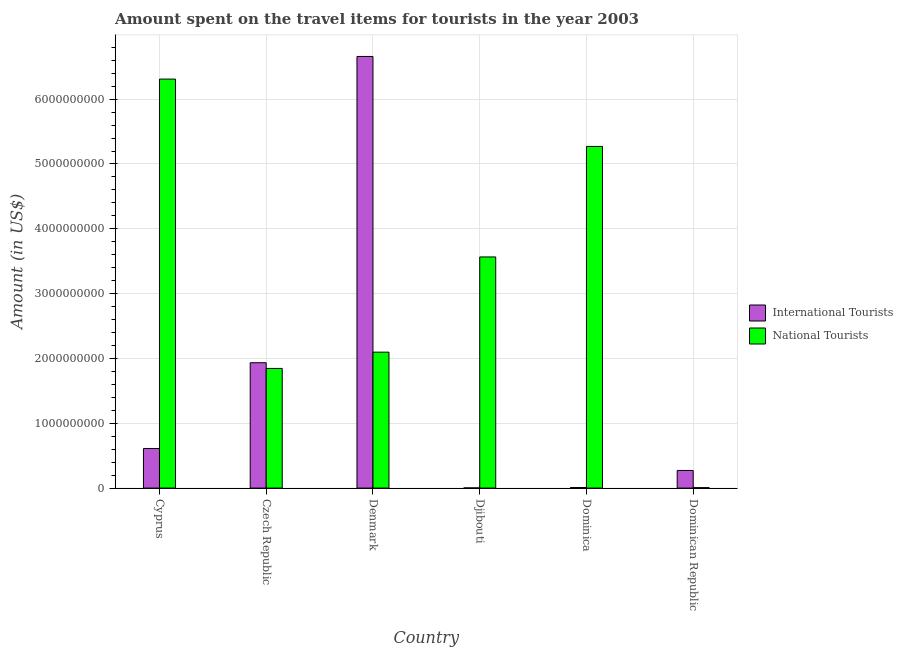How many different coloured bars are there?
Your answer should be compact. 2. Are the number of bars per tick equal to the number of legend labels?
Make the answer very short. Yes. How many bars are there on the 4th tick from the left?
Your answer should be very brief. 2. How many bars are there on the 2nd tick from the right?
Offer a terse response. 2. What is the label of the 4th group of bars from the left?
Give a very brief answer. Djibouti. What is the amount spent on travel items of national tourists in Djibouti?
Ensure brevity in your answer.  3.57e+09. Across all countries, what is the maximum amount spent on travel items of national tourists?
Your answer should be very brief. 6.31e+09. Across all countries, what is the minimum amount spent on travel items of national tourists?
Provide a short and direct response. 6.90e+06. In which country was the amount spent on travel items of national tourists maximum?
Offer a terse response. Cyprus. In which country was the amount spent on travel items of international tourists minimum?
Ensure brevity in your answer.  Djibouti. What is the total amount spent on travel items of national tourists in the graph?
Offer a terse response. 1.91e+1. What is the difference between the amount spent on travel items of international tourists in Cyprus and that in Djibouti?
Provide a short and direct response. 6.08e+08. What is the difference between the amount spent on travel items of international tourists in Denmark and the amount spent on travel items of national tourists in Djibouti?
Keep it short and to the point. 3.09e+09. What is the average amount spent on travel items of national tourists per country?
Ensure brevity in your answer.  3.18e+09. What is the difference between the amount spent on travel items of national tourists and amount spent on travel items of international tourists in Denmark?
Your answer should be very brief. -4.56e+09. In how many countries, is the amount spent on travel items of national tourists greater than 6000000000 US$?
Make the answer very short. 1. What is the ratio of the amount spent on travel items of international tourists in Czech Republic to that in Djibouti?
Provide a short and direct response. 690.71. Is the difference between the amount spent on travel items of international tourists in Cyprus and Dominica greater than the difference between the amount spent on travel items of national tourists in Cyprus and Dominica?
Your response must be concise. No. What is the difference between the highest and the second highest amount spent on travel items of international tourists?
Your answer should be very brief. 4.72e+09. What is the difference between the highest and the lowest amount spent on travel items of international tourists?
Offer a very short reply. 6.66e+09. Is the sum of the amount spent on travel items of international tourists in Djibouti and Dominican Republic greater than the maximum amount spent on travel items of national tourists across all countries?
Provide a short and direct response. No. What does the 2nd bar from the left in Dominican Republic represents?
Your answer should be very brief. National Tourists. What does the 1st bar from the right in Dominica represents?
Your response must be concise. National Tourists. How many bars are there?
Provide a succinct answer. 12. Where does the legend appear in the graph?
Make the answer very short. Center right. What is the title of the graph?
Offer a terse response. Amount spent on the travel items for tourists in the year 2003. Does "Number of arrivals" appear as one of the legend labels in the graph?
Your response must be concise. No. What is the Amount (in US$) in International Tourists in Cyprus?
Provide a succinct answer. 6.11e+08. What is the Amount (in US$) of National Tourists in Cyprus?
Offer a very short reply. 6.31e+09. What is the Amount (in US$) of International Tourists in Czech Republic?
Your response must be concise. 1.93e+09. What is the Amount (in US$) in National Tourists in Czech Republic?
Your response must be concise. 1.85e+09. What is the Amount (in US$) in International Tourists in Denmark?
Give a very brief answer. 6.66e+09. What is the Amount (in US$) of National Tourists in Denmark?
Give a very brief answer. 2.10e+09. What is the Amount (in US$) of International Tourists in Djibouti?
Your answer should be very brief. 2.80e+06. What is the Amount (in US$) of National Tourists in Djibouti?
Offer a very short reply. 3.57e+09. What is the Amount (in US$) of International Tourists in Dominica?
Give a very brief answer. 9.00e+06. What is the Amount (in US$) of National Tourists in Dominica?
Your response must be concise. 5.27e+09. What is the Amount (in US$) of International Tourists in Dominican Republic?
Keep it short and to the point. 2.72e+08. What is the Amount (in US$) in National Tourists in Dominican Republic?
Provide a short and direct response. 6.90e+06. Across all countries, what is the maximum Amount (in US$) in International Tourists?
Provide a short and direct response. 6.66e+09. Across all countries, what is the maximum Amount (in US$) in National Tourists?
Make the answer very short. 6.31e+09. Across all countries, what is the minimum Amount (in US$) of International Tourists?
Provide a succinct answer. 2.80e+06. Across all countries, what is the minimum Amount (in US$) in National Tourists?
Your answer should be very brief. 6.90e+06. What is the total Amount (in US$) of International Tourists in the graph?
Provide a short and direct response. 9.49e+09. What is the total Amount (in US$) in National Tourists in the graph?
Provide a short and direct response. 1.91e+1. What is the difference between the Amount (in US$) in International Tourists in Cyprus and that in Czech Republic?
Offer a terse response. -1.32e+09. What is the difference between the Amount (in US$) of National Tourists in Cyprus and that in Czech Republic?
Provide a short and direct response. 4.46e+09. What is the difference between the Amount (in US$) in International Tourists in Cyprus and that in Denmark?
Make the answer very short. -6.05e+09. What is the difference between the Amount (in US$) of National Tourists in Cyprus and that in Denmark?
Your answer should be very brief. 4.21e+09. What is the difference between the Amount (in US$) in International Tourists in Cyprus and that in Djibouti?
Keep it short and to the point. 6.08e+08. What is the difference between the Amount (in US$) of National Tourists in Cyprus and that in Djibouti?
Provide a succinct answer. 2.74e+09. What is the difference between the Amount (in US$) of International Tourists in Cyprus and that in Dominica?
Provide a succinct answer. 6.02e+08. What is the difference between the Amount (in US$) in National Tourists in Cyprus and that in Dominica?
Your answer should be compact. 1.04e+09. What is the difference between the Amount (in US$) in International Tourists in Cyprus and that in Dominican Republic?
Keep it short and to the point. 3.39e+08. What is the difference between the Amount (in US$) of National Tourists in Cyprus and that in Dominican Republic?
Ensure brevity in your answer.  6.30e+09. What is the difference between the Amount (in US$) in International Tourists in Czech Republic and that in Denmark?
Make the answer very short. -4.72e+09. What is the difference between the Amount (in US$) of National Tourists in Czech Republic and that in Denmark?
Give a very brief answer. -2.51e+08. What is the difference between the Amount (in US$) in International Tourists in Czech Republic and that in Djibouti?
Provide a succinct answer. 1.93e+09. What is the difference between the Amount (in US$) in National Tourists in Czech Republic and that in Djibouti?
Provide a succinct answer. -1.72e+09. What is the difference between the Amount (in US$) of International Tourists in Czech Republic and that in Dominica?
Offer a very short reply. 1.92e+09. What is the difference between the Amount (in US$) of National Tourists in Czech Republic and that in Dominica?
Offer a terse response. -3.42e+09. What is the difference between the Amount (in US$) in International Tourists in Czech Republic and that in Dominican Republic?
Give a very brief answer. 1.66e+09. What is the difference between the Amount (in US$) of National Tourists in Czech Republic and that in Dominican Republic?
Your answer should be very brief. 1.84e+09. What is the difference between the Amount (in US$) in International Tourists in Denmark and that in Djibouti?
Your answer should be very brief. 6.66e+09. What is the difference between the Amount (in US$) in National Tourists in Denmark and that in Djibouti?
Keep it short and to the point. -1.47e+09. What is the difference between the Amount (in US$) in International Tourists in Denmark and that in Dominica?
Offer a terse response. 6.65e+09. What is the difference between the Amount (in US$) of National Tourists in Denmark and that in Dominica?
Make the answer very short. -3.17e+09. What is the difference between the Amount (in US$) of International Tourists in Denmark and that in Dominican Republic?
Keep it short and to the point. 6.39e+09. What is the difference between the Amount (in US$) in National Tourists in Denmark and that in Dominican Republic?
Make the answer very short. 2.09e+09. What is the difference between the Amount (in US$) of International Tourists in Djibouti and that in Dominica?
Provide a succinct answer. -6.20e+06. What is the difference between the Amount (in US$) of National Tourists in Djibouti and that in Dominica?
Give a very brief answer. -1.70e+09. What is the difference between the Amount (in US$) in International Tourists in Djibouti and that in Dominican Republic?
Make the answer very short. -2.69e+08. What is the difference between the Amount (in US$) in National Tourists in Djibouti and that in Dominican Republic?
Offer a very short reply. 3.56e+09. What is the difference between the Amount (in US$) in International Tourists in Dominica and that in Dominican Republic?
Your response must be concise. -2.63e+08. What is the difference between the Amount (in US$) in National Tourists in Dominica and that in Dominican Republic?
Offer a very short reply. 5.26e+09. What is the difference between the Amount (in US$) of International Tourists in Cyprus and the Amount (in US$) of National Tourists in Czech Republic?
Your answer should be compact. -1.24e+09. What is the difference between the Amount (in US$) of International Tourists in Cyprus and the Amount (in US$) of National Tourists in Denmark?
Make the answer very short. -1.49e+09. What is the difference between the Amount (in US$) of International Tourists in Cyprus and the Amount (in US$) of National Tourists in Djibouti?
Your answer should be compact. -2.96e+09. What is the difference between the Amount (in US$) of International Tourists in Cyprus and the Amount (in US$) of National Tourists in Dominica?
Keep it short and to the point. -4.66e+09. What is the difference between the Amount (in US$) of International Tourists in Cyprus and the Amount (in US$) of National Tourists in Dominican Republic?
Give a very brief answer. 6.04e+08. What is the difference between the Amount (in US$) in International Tourists in Czech Republic and the Amount (in US$) in National Tourists in Denmark?
Provide a short and direct response. -1.63e+08. What is the difference between the Amount (in US$) in International Tourists in Czech Republic and the Amount (in US$) in National Tourists in Djibouti?
Offer a terse response. -1.63e+09. What is the difference between the Amount (in US$) in International Tourists in Czech Republic and the Amount (in US$) in National Tourists in Dominica?
Your response must be concise. -3.34e+09. What is the difference between the Amount (in US$) of International Tourists in Czech Republic and the Amount (in US$) of National Tourists in Dominican Republic?
Offer a very short reply. 1.93e+09. What is the difference between the Amount (in US$) of International Tourists in Denmark and the Amount (in US$) of National Tourists in Djibouti?
Give a very brief answer. 3.09e+09. What is the difference between the Amount (in US$) of International Tourists in Denmark and the Amount (in US$) of National Tourists in Dominica?
Ensure brevity in your answer.  1.39e+09. What is the difference between the Amount (in US$) of International Tourists in Denmark and the Amount (in US$) of National Tourists in Dominican Republic?
Make the answer very short. 6.65e+09. What is the difference between the Amount (in US$) of International Tourists in Djibouti and the Amount (in US$) of National Tourists in Dominica?
Provide a short and direct response. -5.27e+09. What is the difference between the Amount (in US$) of International Tourists in Djibouti and the Amount (in US$) of National Tourists in Dominican Republic?
Make the answer very short. -4.10e+06. What is the difference between the Amount (in US$) in International Tourists in Dominica and the Amount (in US$) in National Tourists in Dominican Republic?
Your answer should be compact. 2.10e+06. What is the average Amount (in US$) in International Tourists per country?
Provide a succinct answer. 1.58e+09. What is the average Amount (in US$) of National Tourists per country?
Give a very brief answer. 3.18e+09. What is the difference between the Amount (in US$) of International Tourists and Amount (in US$) of National Tourists in Cyprus?
Your response must be concise. -5.70e+09. What is the difference between the Amount (in US$) in International Tourists and Amount (in US$) in National Tourists in Czech Republic?
Your answer should be very brief. 8.80e+07. What is the difference between the Amount (in US$) of International Tourists and Amount (in US$) of National Tourists in Denmark?
Keep it short and to the point. 4.56e+09. What is the difference between the Amount (in US$) in International Tourists and Amount (in US$) in National Tourists in Djibouti?
Provide a succinct answer. -3.56e+09. What is the difference between the Amount (in US$) in International Tourists and Amount (in US$) in National Tourists in Dominica?
Keep it short and to the point. -5.26e+09. What is the difference between the Amount (in US$) of International Tourists and Amount (in US$) of National Tourists in Dominican Republic?
Your response must be concise. 2.65e+08. What is the ratio of the Amount (in US$) in International Tourists in Cyprus to that in Czech Republic?
Ensure brevity in your answer.  0.32. What is the ratio of the Amount (in US$) in National Tourists in Cyprus to that in Czech Republic?
Provide a succinct answer. 3.42. What is the ratio of the Amount (in US$) of International Tourists in Cyprus to that in Denmark?
Provide a short and direct response. 0.09. What is the ratio of the Amount (in US$) of National Tourists in Cyprus to that in Denmark?
Provide a succinct answer. 3.01. What is the ratio of the Amount (in US$) in International Tourists in Cyprus to that in Djibouti?
Ensure brevity in your answer.  218.21. What is the ratio of the Amount (in US$) of National Tourists in Cyprus to that in Djibouti?
Offer a terse response. 1.77. What is the ratio of the Amount (in US$) of International Tourists in Cyprus to that in Dominica?
Your response must be concise. 67.89. What is the ratio of the Amount (in US$) in National Tourists in Cyprus to that in Dominica?
Offer a terse response. 1.2. What is the ratio of the Amount (in US$) in International Tourists in Cyprus to that in Dominican Republic?
Your response must be concise. 2.25. What is the ratio of the Amount (in US$) in National Tourists in Cyprus to that in Dominican Republic?
Provide a succinct answer. 914.49. What is the ratio of the Amount (in US$) of International Tourists in Czech Republic to that in Denmark?
Make the answer very short. 0.29. What is the ratio of the Amount (in US$) in National Tourists in Czech Republic to that in Denmark?
Make the answer very short. 0.88. What is the ratio of the Amount (in US$) of International Tourists in Czech Republic to that in Djibouti?
Provide a short and direct response. 690.71. What is the ratio of the Amount (in US$) of National Tourists in Czech Republic to that in Djibouti?
Keep it short and to the point. 0.52. What is the ratio of the Amount (in US$) in International Tourists in Czech Republic to that in Dominica?
Offer a terse response. 214.89. What is the ratio of the Amount (in US$) in National Tourists in Czech Republic to that in Dominica?
Your response must be concise. 0.35. What is the ratio of the Amount (in US$) in International Tourists in Czech Republic to that in Dominican Republic?
Provide a succinct answer. 7.11. What is the ratio of the Amount (in US$) in National Tourists in Czech Republic to that in Dominican Republic?
Give a very brief answer. 267.54. What is the ratio of the Amount (in US$) of International Tourists in Denmark to that in Djibouti?
Provide a short and direct response. 2378.21. What is the ratio of the Amount (in US$) in National Tourists in Denmark to that in Djibouti?
Offer a terse response. 0.59. What is the ratio of the Amount (in US$) in International Tourists in Denmark to that in Dominica?
Offer a terse response. 739.89. What is the ratio of the Amount (in US$) of National Tourists in Denmark to that in Dominica?
Offer a very short reply. 0.4. What is the ratio of the Amount (in US$) of International Tourists in Denmark to that in Dominican Republic?
Your answer should be compact. 24.48. What is the ratio of the Amount (in US$) of National Tourists in Denmark to that in Dominican Republic?
Your response must be concise. 303.91. What is the ratio of the Amount (in US$) of International Tourists in Djibouti to that in Dominica?
Your response must be concise. 0.31. What is the ratio of the Amount (in US$) in National Tourists in Djibouti to that in Dominica?
Your answer should be very brief. 0.68. What is the ratio of the Amount (in US$) of International Tourists in Djibouti to that in Dominican Republic?
Your answer should be compact. 0.01. What is the ratio of the Amount (in US$) in National Tourists in Djibouti to that in Dominican Republic?
Give a very brief answer. 516.81. What is the ratio of the Amount (in US$) in International Tourists in Dominica to that in Dominican Republic?
Your answer should be very brief. 0.03. What is the ratio of the Amount (in US$) of National Tourists in Dominica to that in Dominican Republic?
Give a very brief answer. 763.91. What is the difference between the highest and the second highest Amount (in US$) in International Tourists?
Ensure brevity in your answer.  4.72e+09. What is the difference between the highest and the second highest Amount (in US$) in National Tourists?
Ensure brevity in your answer.  1.04e+09. What is the difference between the highest and the lowest Amount (in US$) in International Tourists?
Your response must be concise. 6.66e+09. What is the difference between the highest and the lowest Amount (in US$) in National Tourists?
Your answer should be compact. 6.30e+09. 